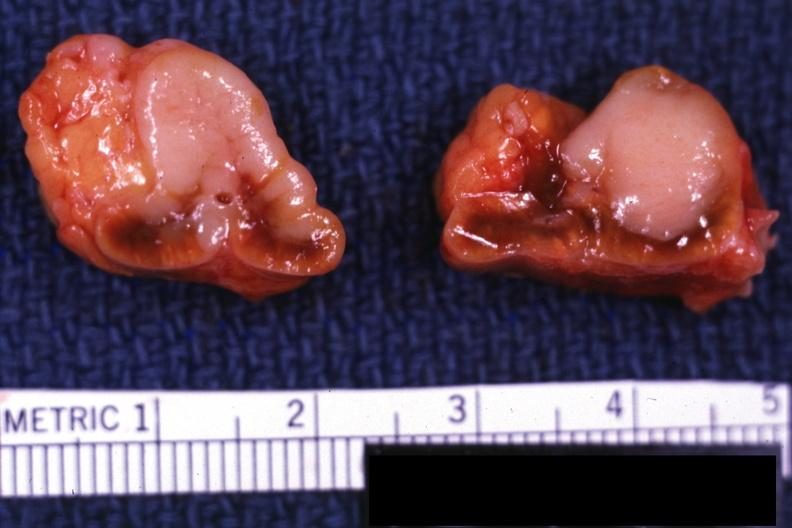what is present?
Answer the question using a single word or phrase. Endocrine 